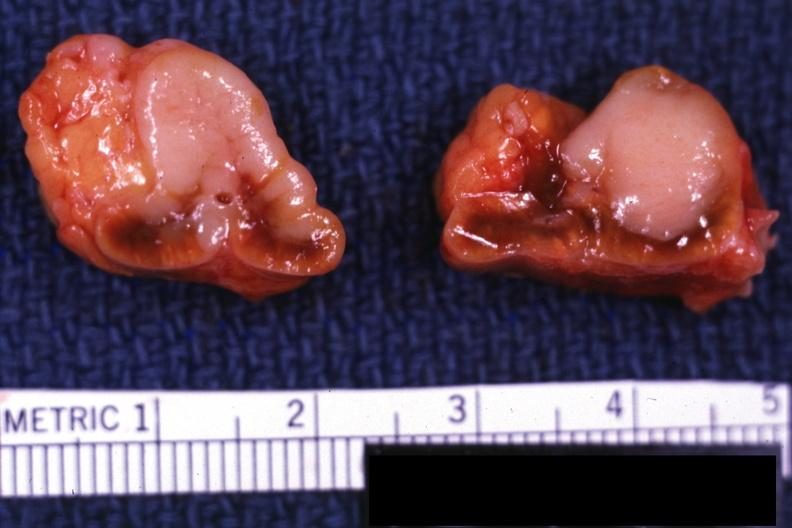what is present?
Answer the question using a single word or phrase. Endocrine 